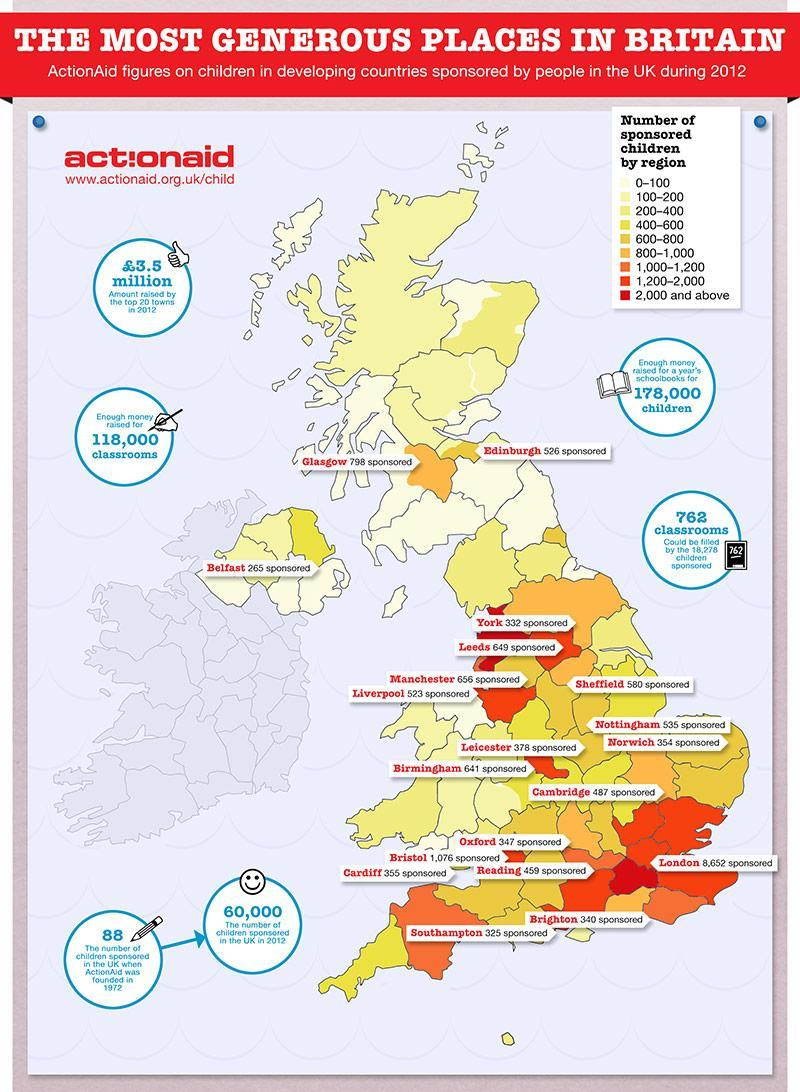Which region has the higher number of children sponsored in 2012 - Liverpool or Manchester?
Answer the question with a short phrase. Manchester Which region has the lower number of children sponsored in 2012 - Cambridge or oxford?? oxford Which number is written closer to the book icon? 178000 Which number is written closer to the pencil icon? 88 What are the total number of children sponsored by ActionAid in 1972 and in 2012 respectively? 88, 60000 Which region has the highest number of children sponsored? London Which region has the lowest number of sponsored children? Belfast Which region has the second highest number of sponsored children? Bristol How many regions' data of sponsored children is given in this infographic? 20 Among the regions Oxford, Bristol, Cardiff and Reading, Which region has the highest number of sponsored children? Bristol When was ActionAid founded? 1972 